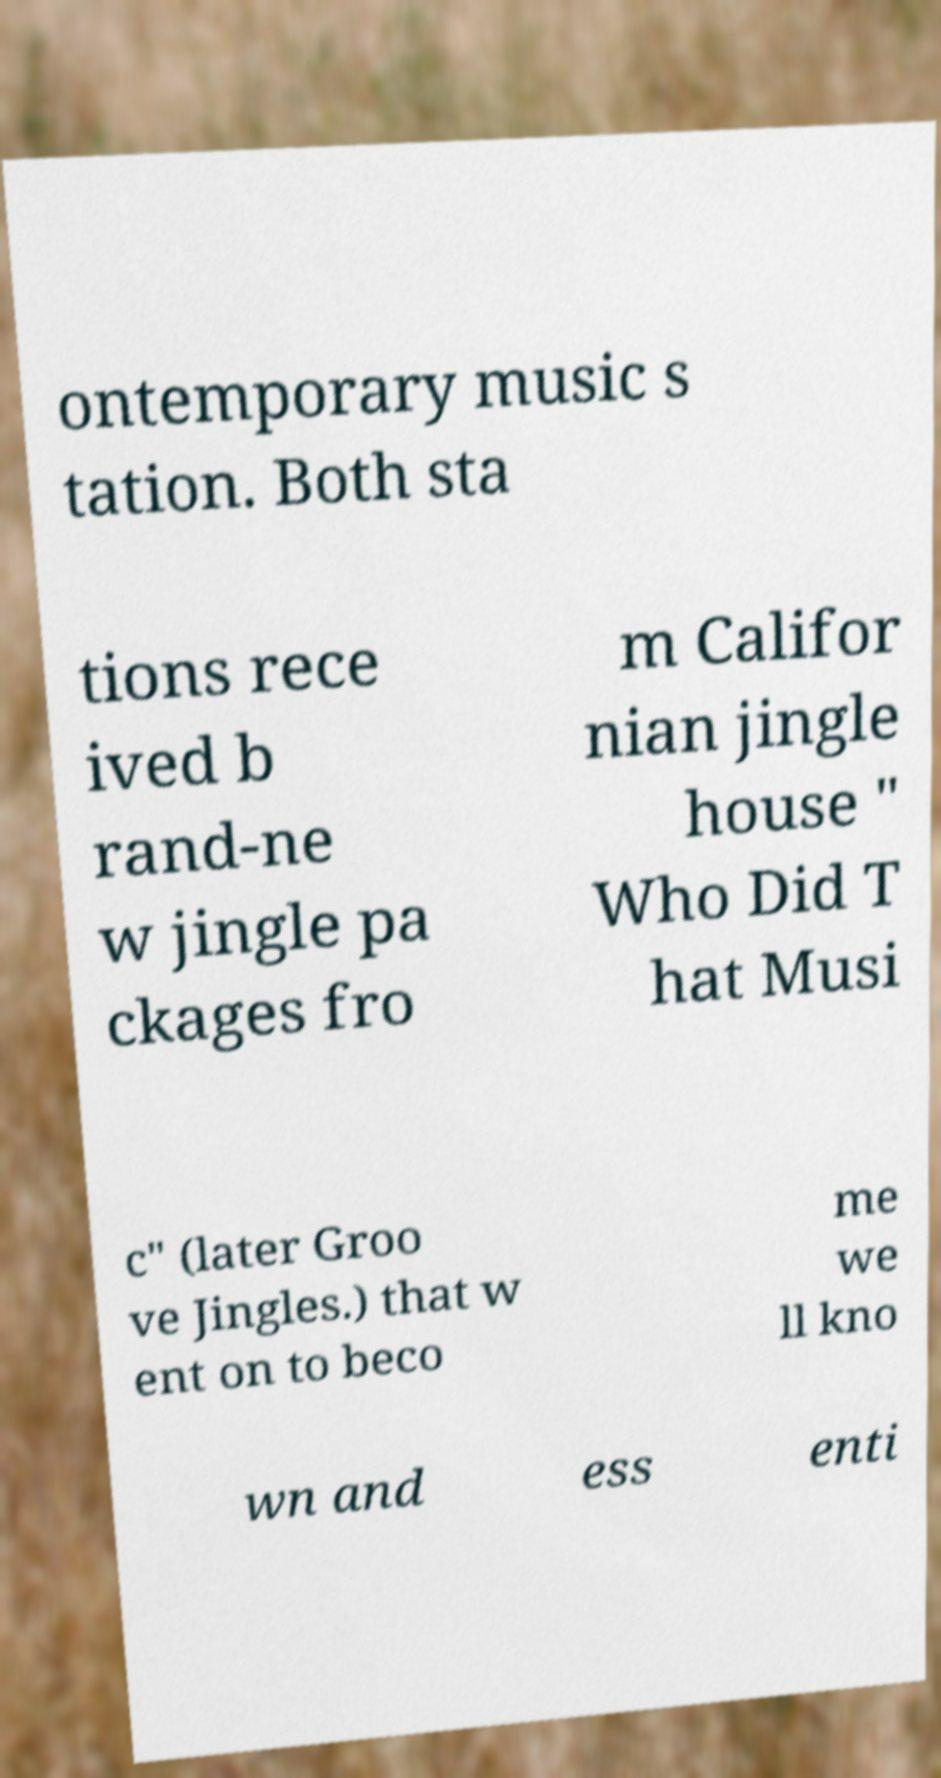I need the written content from this picture converted into text. Can you do that? ontemporary music s tation. Both sta tions rece ived b rand-ne w jingle pa ckages fro m Califor nian jingle house " Who Did T hat Musi c" (later Groo ve Jingles.) that w ent on to beco me we ll kno wn and ess enti 